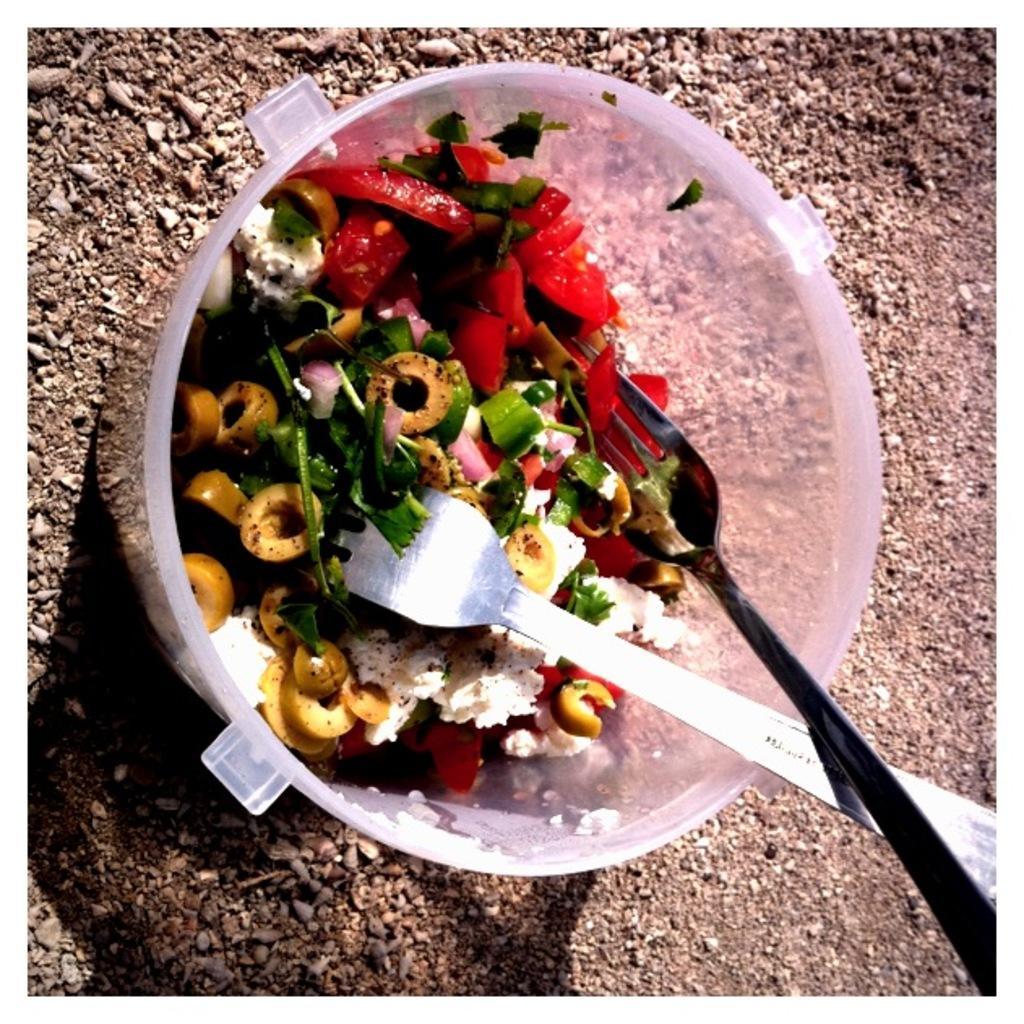Describe this image in one or two sentences. In this picture we can see a bowl and stones on the ground. In this bowl we can see food and forks. 